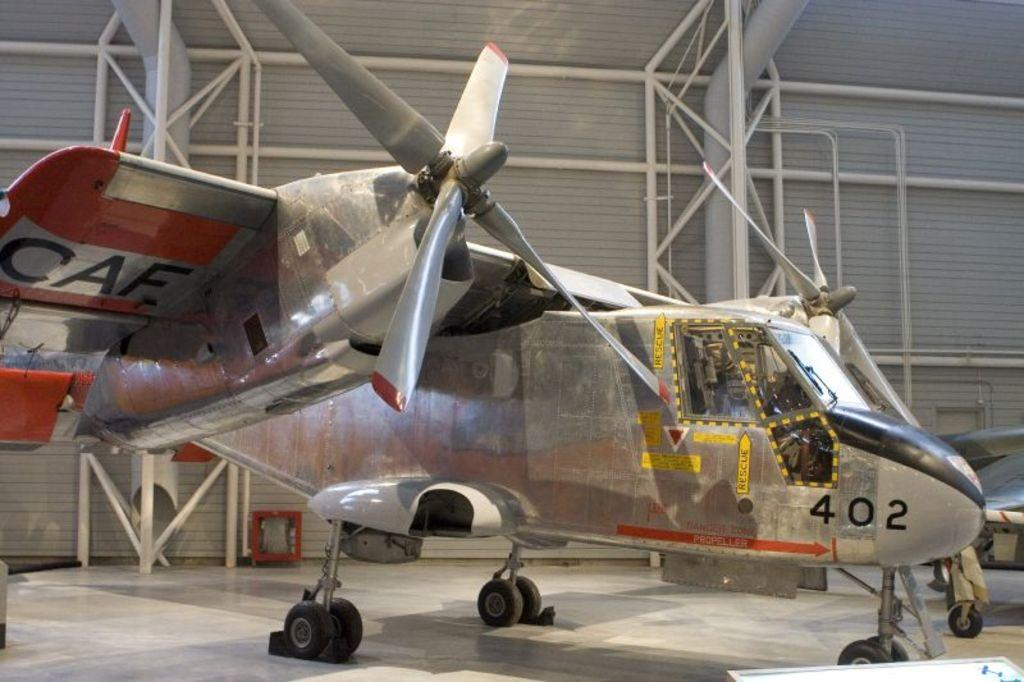Provide a one-sentence caption for the provided image. A silver CAF plane sitting inside an aircraft hanger with the number 402. 